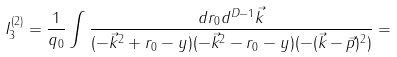Convert formula to latex. <formula><loc_0><loc_0><loc_500><loc_500>I _ { 3 } ^ { ( 2 ) } = \frac { 1 } { q _ { 0 } } \int \frac { d r _ { 0 } d ^ { D - 1 } \vec { k } } { ( - \vec { k } ^ { 2 } + r _ { 0 } - y ) ( - \vec { k } ^ { 2 } - r _ { 0 } - y ) ( - ( \vec { k } - \vec { p } ) ^ { 2 } ) } =</formula> 